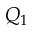<formula> <loc_0><loc_0><loc_500><loc_500>Q _ { 1 }</formula> 